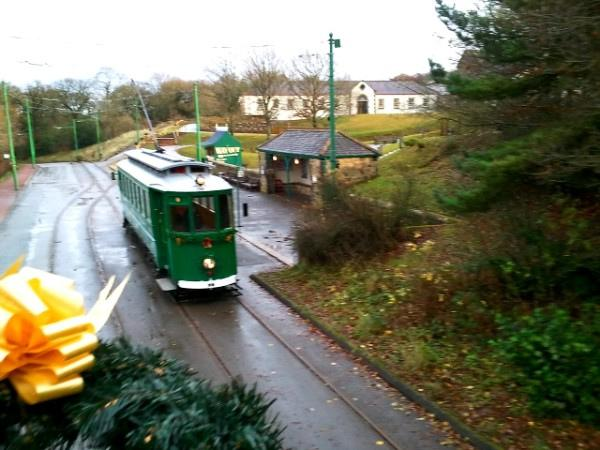What holiday is most likely next? christmas 